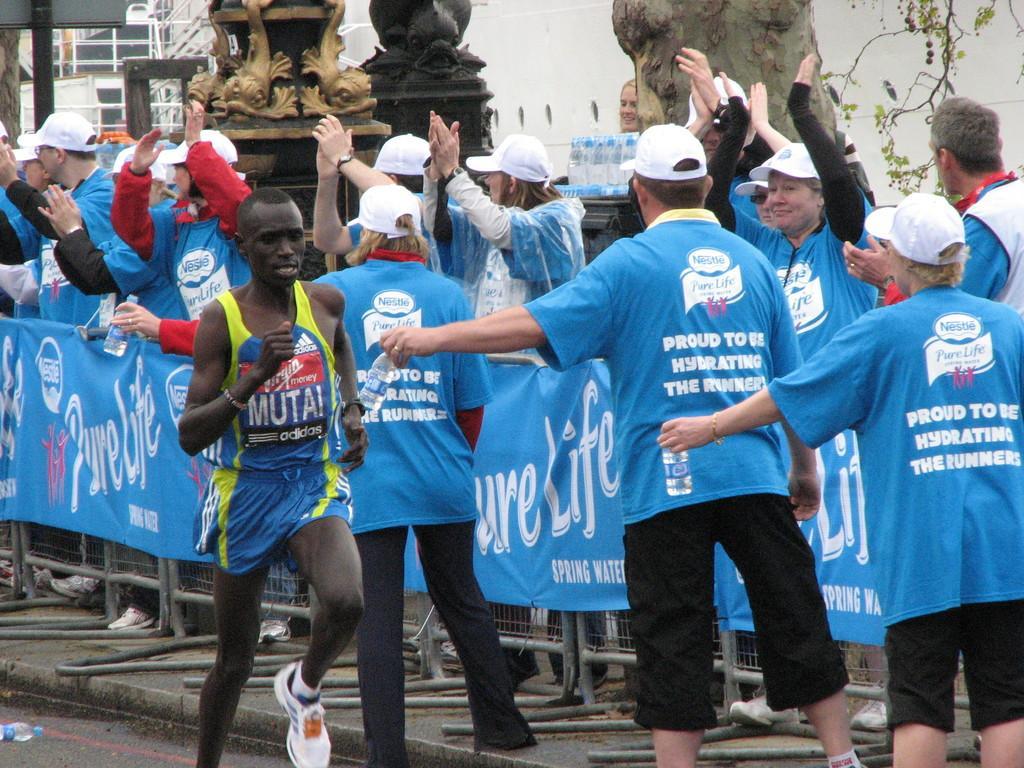Could you give a brief overview of what you see in this image? In this image I can see one person running. To the side of that person I can see the group of people with blue color t-shirts and caps. And there is a banner attached to the railing. In the background I can see the statues, water bottles, tree and the building. 